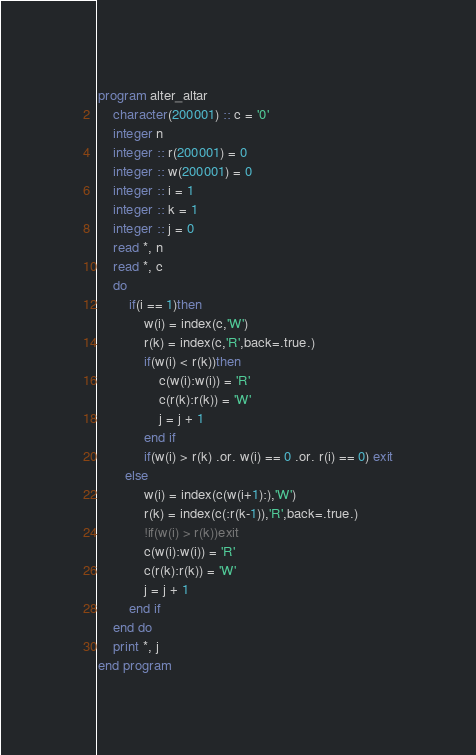<code> <loc_0><loc_0><loc_500><loc_500><_FORTRAN_>program alter_altar
    character(200001) :: c = '0'
    integer n
    integer :: r(200001) = 0
    integer :: w(200001) = 0
    integer :: i = 1
    integer :: k = 1
    integer :: j = 0
    read *, n
    read *, c
    do
        if(i == 1)then
            w(i) = index(c,'W')
            r(k) = index(c,'R',back=.true.)
            if(w(i) < r(k))then
                c(w(i):w(i)) = 'R'
                c(r(k):r(k)) = 'W'
                j = j + 1
            end if
            if(w(i) > r(k) .or. w(i) == 0 .or. r(i) == 0) exit
       else
            w(i) = index(c(w(i+1):),'W')
            r(k) = index(c(:r(k-1)),'R',back=.true.)
            !if(w(i) > r(k))exit
            c(w(i):w(i)) = 'R'
            c(r(k):r(k)) = 'W'
            j = j + 1
        end if
    end do
    print *, j
end program</code> 